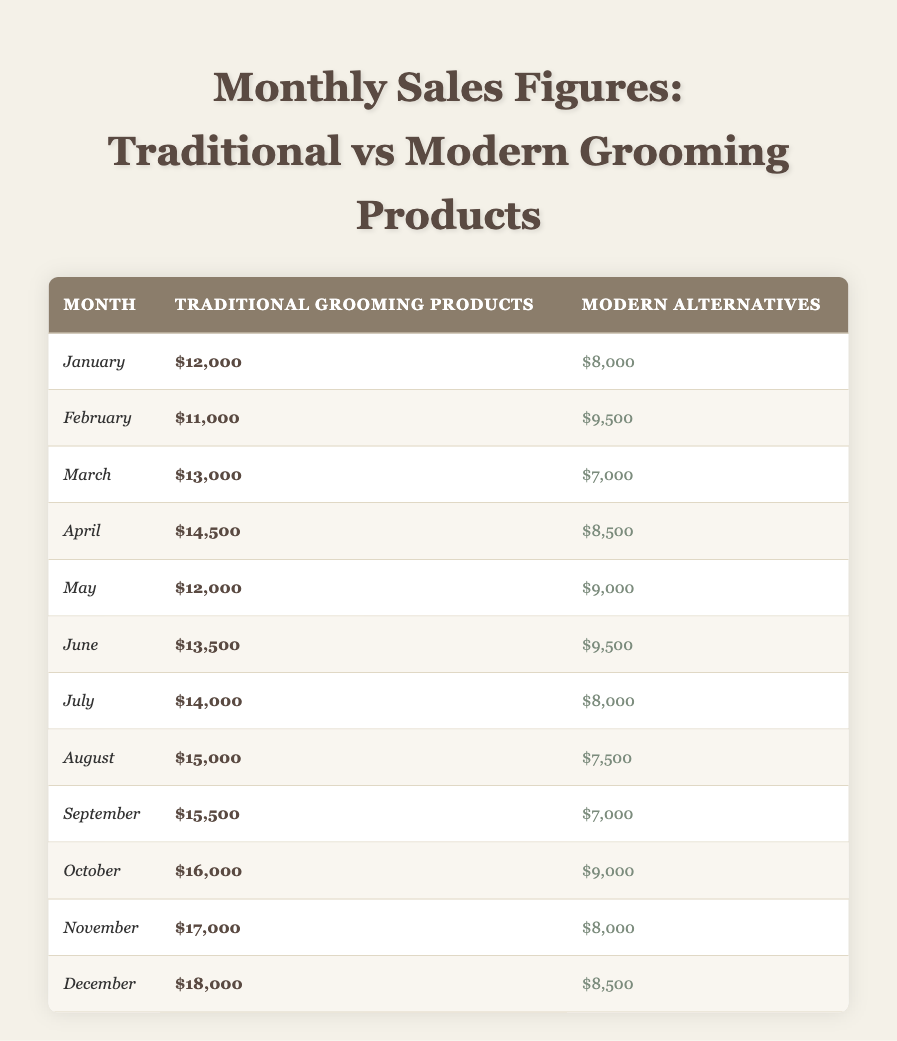What was the traditional grooming product sales in March? The table lists the sales figures for traditional grooming products, where March shows $13,000 in sales.
Answer: $13,000 Which month had the highest sales for modern alternatives? By reviewing the modern alternatives sales figures, December has the highest sales at $8,500.
Answer: December What was the total sales for traditional grooming products from January to June? To find the total, add the figures: $12,000 (Jan) + $11,000 (Feb) + $13,000 (Mar) + $14,500 (Apr) + $12,000 (May) + $13,500 (Jun) = $76,000.
Answer: $76,000 Did traditional grooming products ever have lower sales than modern alternatives in any month? A comparison of the figures shows that traditional grooming products have consistently higher sales than modern alternatives in every month listed, so the statement is false.
Answer: No What is the average monthly sales for traditional grooming products over the entire year? To calculate the average, sum all the traditional grooming product sales ($12,000 + $11,000 + $13,000 + $14,500 + $12,000 + $13,500 + $14,000 + $15,000 + $15,500 + $16,000 + $17,000 + $18,000 = $171,000) and divide by the number of months (12): $171,000 / 12 = $14,250.
Answer: $14,250 In which month did traditional grooming products see the least sales? Reviewing the table for the minimum sales figure for traditional grooming products shows February with $11,000 as the least sales.
Answer: February How much more did traditional grooming products outsell modern alternatives in November? The difference in sales for November is $17,000 (traditional) - $8,000 (modern) = $9,000.
Answer: $9,000 What is the trend observed in sales for modern alternatives from January to December? By analyzing the modern alternatives sales across the months, the figures show a general decline in sales from January ($8,000) to September ($7,000), with slight increases in October and December, leading to a fluctuating trend overall.
Answer: Fluctuating trend Which month had the largest difference between traditional and modern sales? Calculating the differences for each month, November has the largest difference: $17,000 (traditional) - $8,000 (modern) = $9,000 difference.
Answer: November What was the total sales for both traditional and modern grooming products in December? Adding December's sales: $18,000 (traditional) + $8,500 (modern) = $26,500 for total sales.
Answer: $26,500 